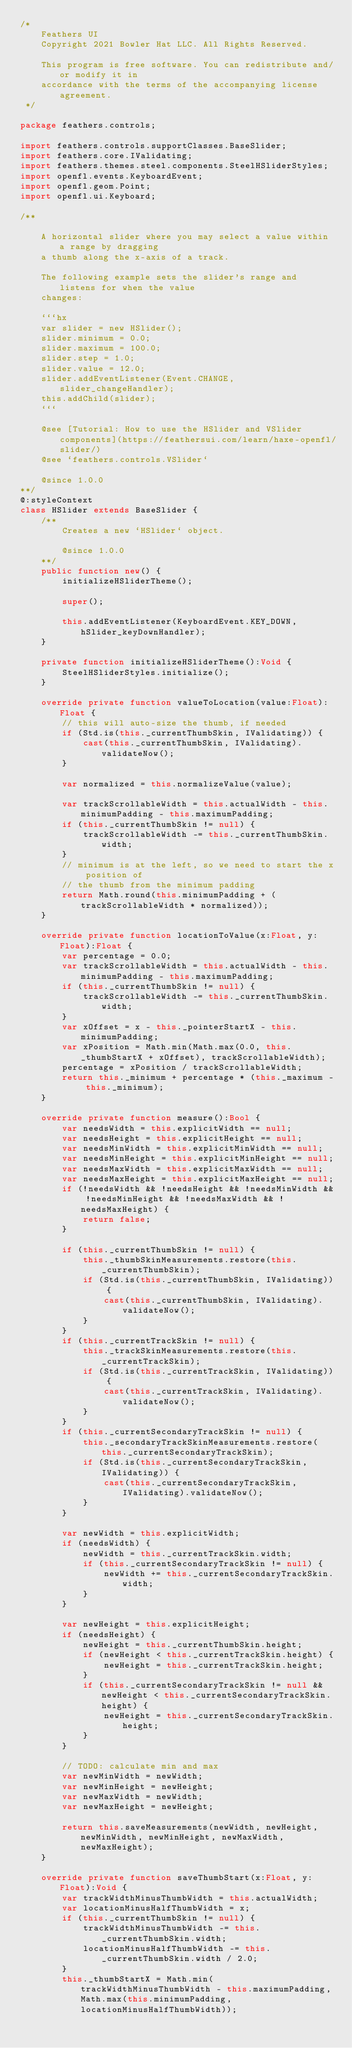<code> <loc_0><loc_0><loc_500><loc_500><_Haxe_>/*
	Feathers UI
	Copyright 2021 Bowler Hat LLC. All Rights Reserved.

	This program is free software. You can redistribute and/or modify it in
	accordance with the terms of the accompanying license agreement.
 */

package feathers.controls;

import feathers.controls.supportClasses.BaseSlider;
import feathers.core.IValidating;
import feathers.themes.steel.components.SteelHSliderStyles;
import openfl.events.KeyboardEvent;
import openfl.geom.Point;
import openfl.ui.Keyboard;

/**

	A horizontal slider where you may select a value within a range by dragging
	a thumb along the x-axis of a track.

	The following example sets the slider's range and listens for when the value
	changes:

	```hx
	var slider = new HSlider();
	slider.minimum = 0.0;
	slider.maximum = 100.0;
	slider.step = 1.0;
	slider.value = 12.0;
	slider.addEventListener(Event.CHANGE, slider_changeHandler);
	this.addChild(slider);
	```

	@see [Tutorial: How to use the HSlider and VSlider components](https://feathersui.com/learn/haxe-openfl/slider/)
	@see `feathers.controls.VSlider`

	@since 1.0.0
**/
@:styleContext
class HSlider extends BaseSlider {
	/**
		Creates a new `HSlider` object.

		@since 1.0.0
	**/
	public function new() {
		initializeHSliderTheme();

		super();

		this.addEventListener(KeyboardEvent.KEY_DOWN, hSlider_keyDownHandler);
	}

	private function initializeHSliderTheme():Void {
		SteelHSliderStyles.initialize();
	}

	override private function valueToLocation(value:Float):Float {
		// this will auto-size the thumb, if needed
		if (Std.is(this._currentThumbSkin, IValidating)) {
			cast(this._currentThumbSkin, IValidating).validateNow();
		}

		var normalized = this.normalizeValue(value);

		var trackScrollableWidth = this.actualWidth - this.minimumPadding - this.maximumPadding;
		if (this._currentThumbSkin != null) {
			trackScrollableWidth -= this._currentThumbSkin.width;
		}
		// minimum is at the left, so we need to start the x position of
		// the thumb from the minimum padding
		return Math.round(this.minimumPadding + (trackScrollableWidth * normalized));
	}

	override private function locationToValue(x:Float, y:Float):Float {
		var percentage = 0.0;
		var trackScrollableWidth = this.actualWidth - this.minimumPadding - this.maximumPadding;
		if (this._currentThumbSkin != null) {
			trackScrollableWidth -= this._currentThumbSkin.width;
		}
		var xOffset = x - this._pointerStartX - this.minimumPadding;
		var xPosition = Math.min(Math.max(0.0, this._thumbStartX + xOffset), trackScrollableWidth);
		percentage = xPosition / trackScrollableWidth;
		return this._minimum + percentage * (this._maximum - this._minimum);
	}

	override private function measure():Bool {
		var needsWidth = this.explicitWidth == null;
		var needsHeight = this.explicitHeight == null;
		var needsMinWidth = this.explicitMinWidth == null;
		var needsMinHeight = this.explicitMinHeight == null;
		var needsMaxWidth = this.explicitMaxWidth == null;
		var needsMaxHeight = this.explicitMaxHeight == null;
		if (!needsWidth && !needsHeight && !needsMinWidth && !needsMinHeight && !needsMaxWidth && !needsMaxHeight) {
			return false;
		}

		if (this._currentThumbSkin != null) {
			this._thumbSkinMeasurements.restore(this._currentThumbSkin);
			if (Std.is(this._currentThumbSkin, IValidating)) {
				cast(this._currentThumbSkin, IValidating).validateNow();
			}
		}
		if (this._currentTrackSkin != null) {
			this._trackSkinMeasurements.restore(this._currentTrackSkin);
			if (Std.is(this._currentTrackSkin, IValidating)) {
				cast(this._currentTrackSkin, IValidating).validateNow();
			}
		}
		if (this._currentSecondaryTrackSkin != null) {
			this._secondaryTrackSkinMeasurements.restore(this._currentSecondaryTrackSkin);
			if (Std.is(this._currentSecondaryTrackSkin, IValidating)) {
				cast(this._currentSecondaryTrackSkin, IValidating).validateNow();
			}
		}

		var newWidth = this.explicitWidth;
		if (needsWidth) {
			newWidth = this._currentTrackSkin.width;
			if (this._currentSecondaryTrackSkin != null) {
				newWidth += this._currentSecondaryTrackSkin.width;
			}
		}

		var newHeight = this.explicitHeight;
		if (needsHeight) {
			newHeight = this._currentThumbSkin.height;
			if (newHeight < this._currentTrackSkin.height) {
				newHeight = this._currentTrackSkin.height;
			}
			if (this._currentSecondaryTrackSkin != null && newHeight < this._currentSecondaryTrackSkin.height) {
				newHeight = this._currentSecondaryTrackSkin.height;
			}
		}

		// TODO: calculate min and max
		var newMinWidth = newWidth;
		var newMinHeight = newHeight;
		var newMaxWidth = newWidth;
		var newMaxHeight = newHeight;

		return this.saveMeasurements(newWidth, newHeight, newMinWidth, newMinHeight, newMaxWidth, newMaxHeight);
	}

	override private function saveThumbStart(x:Float, y:Float):Void {
		var trackWidthMinusThumbWidth = this.actualWidth;
		var locationMinusHalfThumbWidth = x;
		if (this._currentThumbSkin != null) {
			trackWidthMinusThumbWidth -= this._currentThumbSkin.width;
			locationMinusHalfThumbWidth -= this._currentThumbSkin.width / 2.0;
		}
		this._thumbStartX = Math.min(trackWidthMinusThumbWidth - this.maximumPadding, Math.max(this.minimumPadding, locationMinusHalfThumbWidth));</code> 